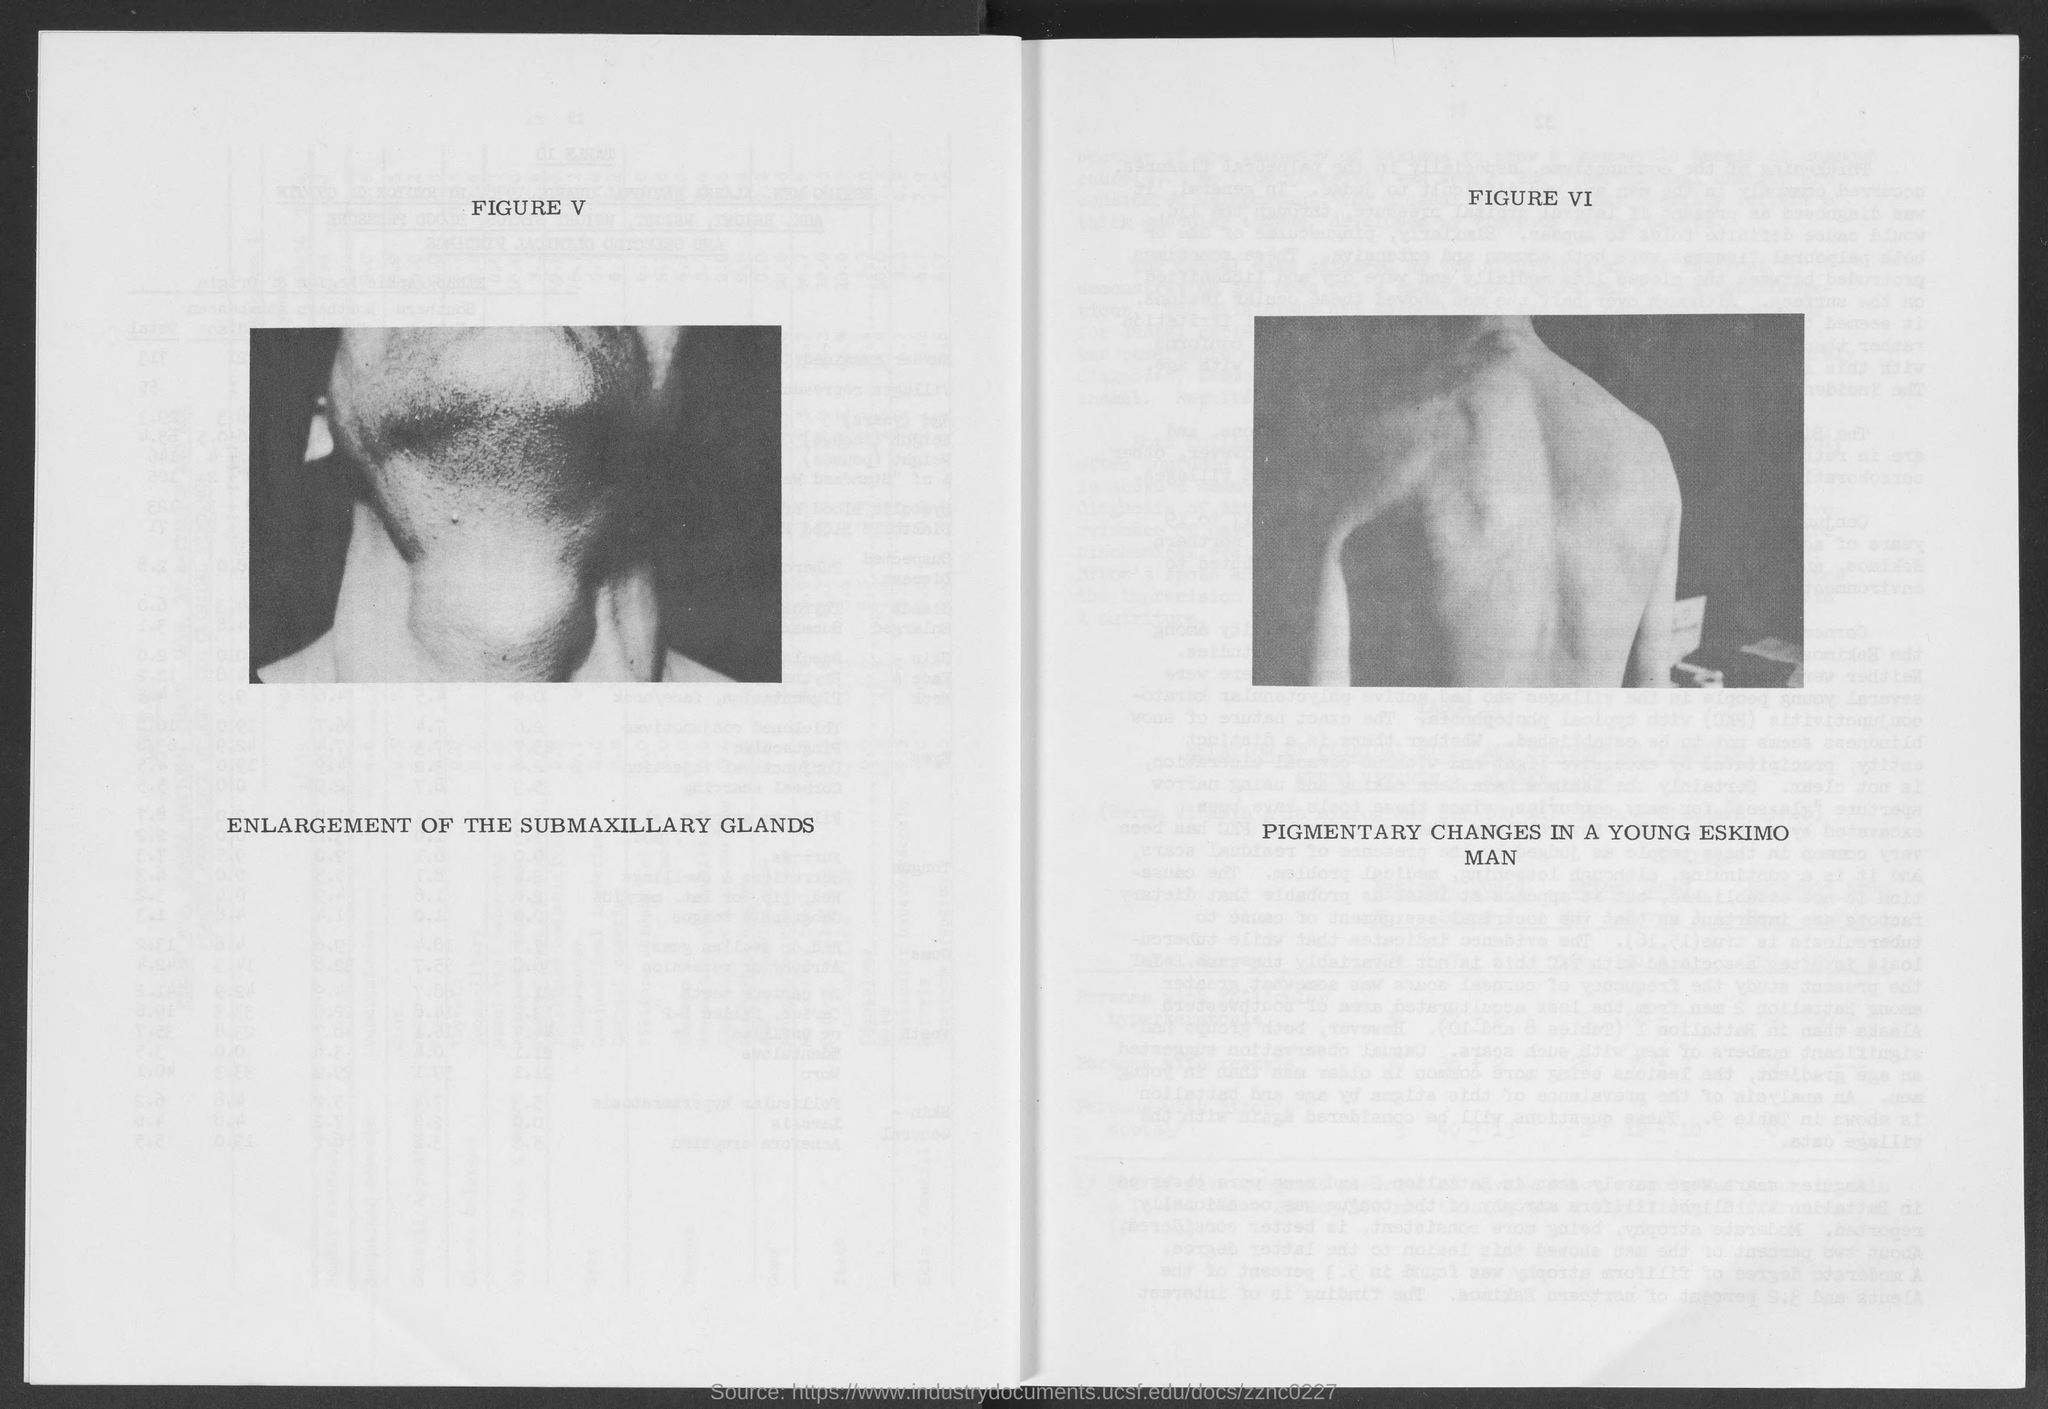Identify some key points in this picture. FIGURE VI in this document describes pigmentary changes in a young Eskimo man. According to the document, "FIGURE V" describes the enlargement of the submaxillary glands. 